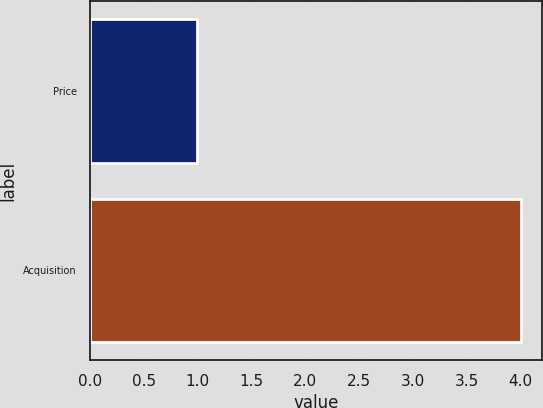<chart> <loc_0><loc_0><loc_500><loc_500><bar_chart><fcel>Price<fcel>Acquisition<nl><fcel>1<fcel>4<nl></chart> 